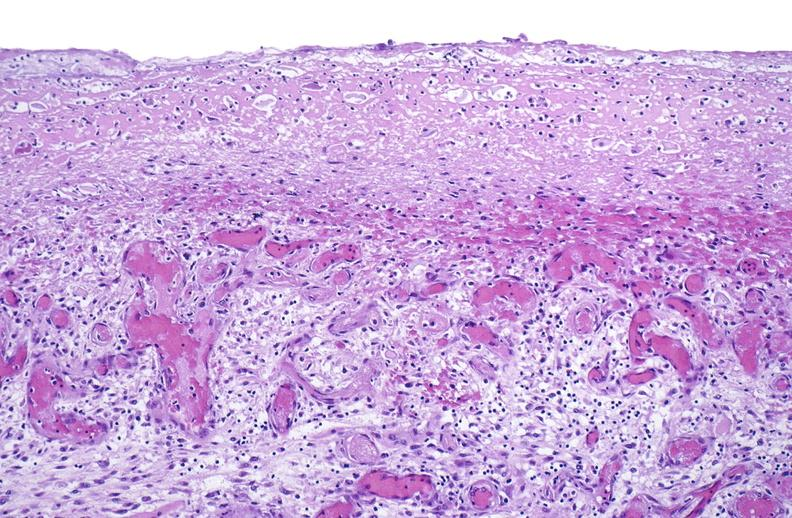s soft tissue present?
Answer the question using a single word or phrase. Yes 